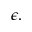Convert formula to latex. <formula><loc_0><loc_0><loc_500><loc_500>\epsilon .</formula> 